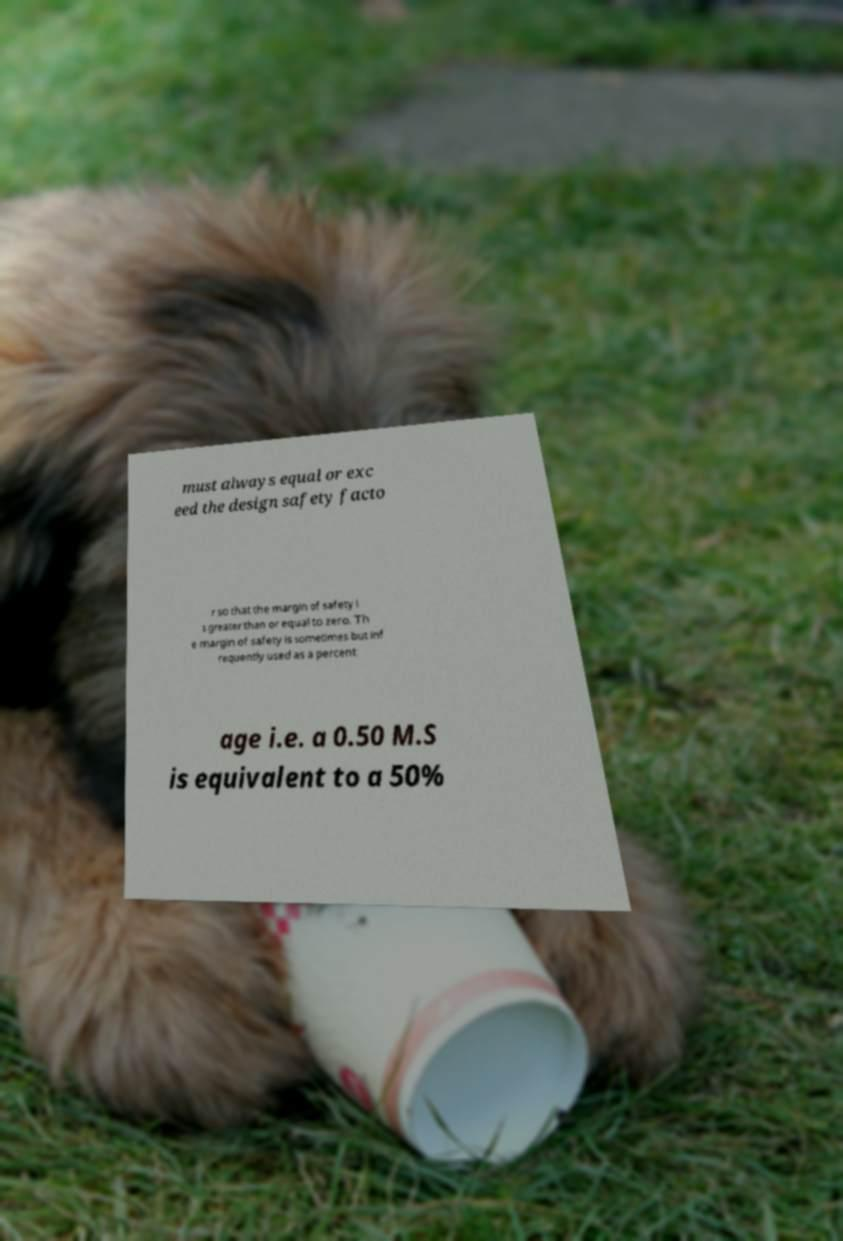Can you accurately transcribe the text from the provided image for me? must always equal or exc eed the design safety facto r so that the margin of safety i s greater than or equal to zero. Th e margin of safety is sometimes but inf requently used as a percent age i.e. a 0.50 M.S is equivalent to a 50% 